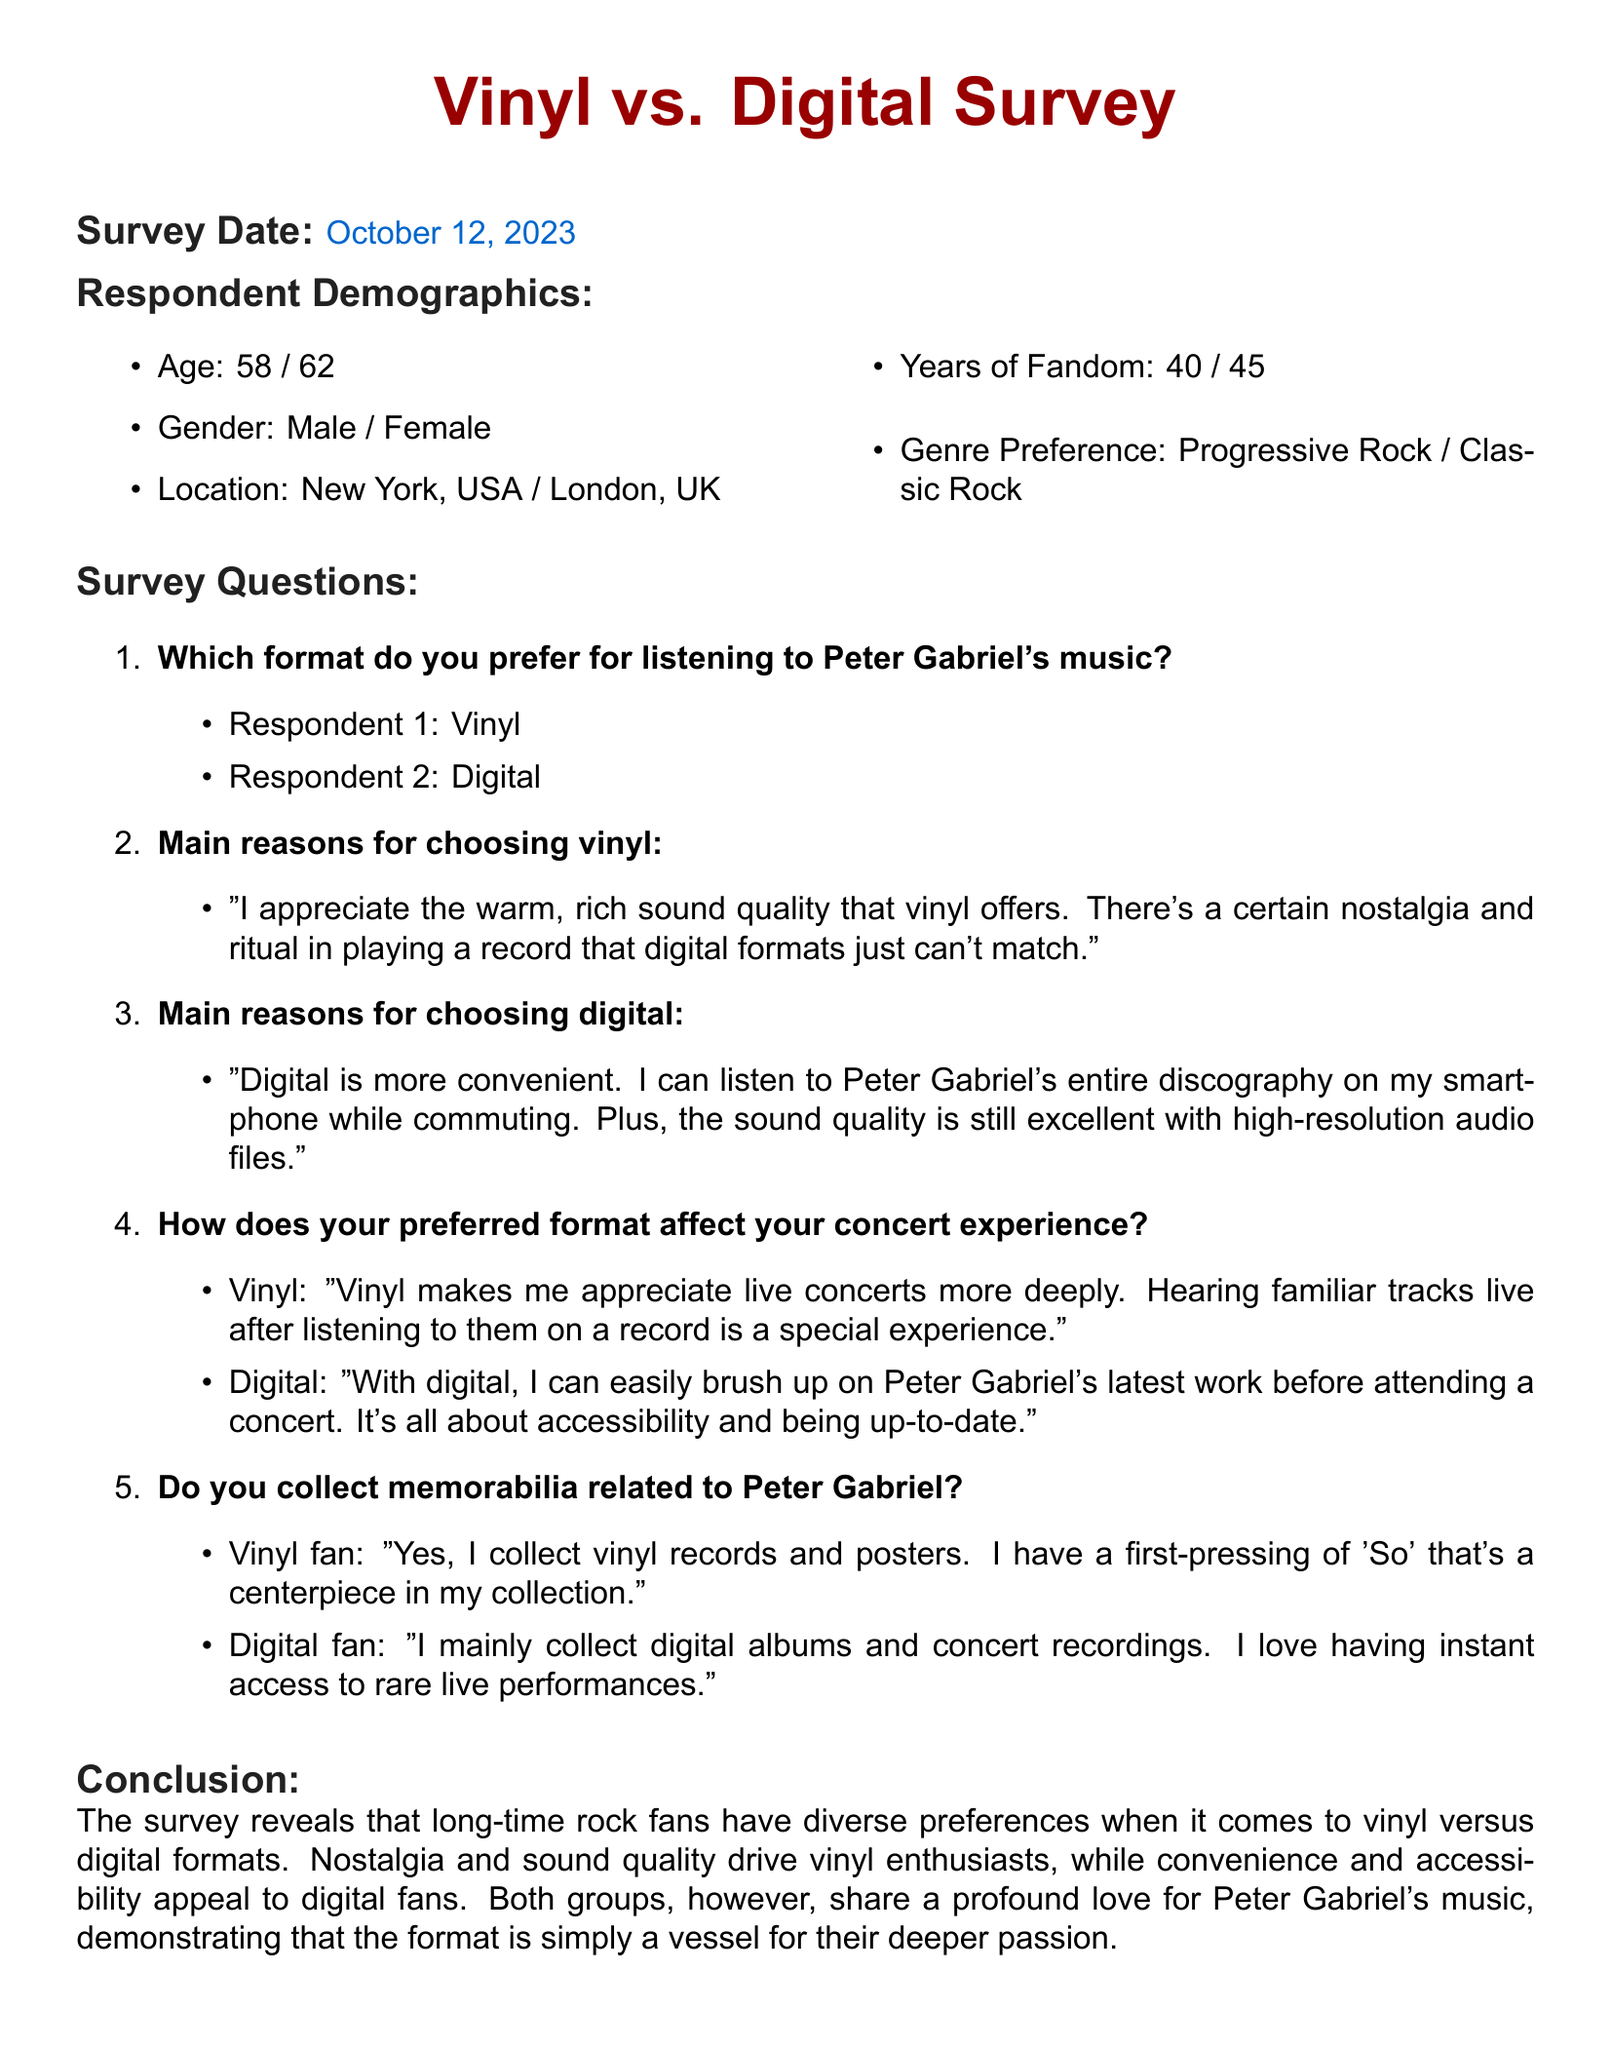what is the survey date? The survey date is provided in the document, which states October 12, 2023.
Answer: October 12, 2023 how many years of fandom does the first respondent have? The first respondent's years of fandom are mentioned as 40 years in the demographics section.
Answer: 40 what is the gender of the second respondent? The second respondent's gender is specified in the demographics part as Female.
Answer: Female which format does the first respondent prefer for listening to Peter Gabriel's music? The document lists the music format preference of the first respondent as Vinyl.
Answer: Vinyl what main reason does the vinyl fan give for their preference? The vinyl fan states their main reason as appreciating the warm, rich sound quality and nostalgia associated with playing records.
Answer: Warm, rich sound quality how does the digital format affect the concert experience according to the digital fan? The digital fan mentions that the digital format allows easy access to Peter Gabriel's latest work before attending a concert.
Answer: Accessibility how does the vinyl fan collect memorabilia related to Peter Gabriel? The vinyl fan mentions collecting vinyl records and posters, particularly a first-pressing of 'So'.
Answer: Vinyl records and posters what conclusion can be drawn about long-time rock fans' format preferences? The conclusion states that long-time rock fans have diverse preferences influenced by nostalgia, sound quality, convenience, and accessibility.
Answer: Diverse preferences what genre does the first respondent prefer? The document indicates that the genre preference of the first respondent is Progressive Rock.
Answer: Progressive Rock 